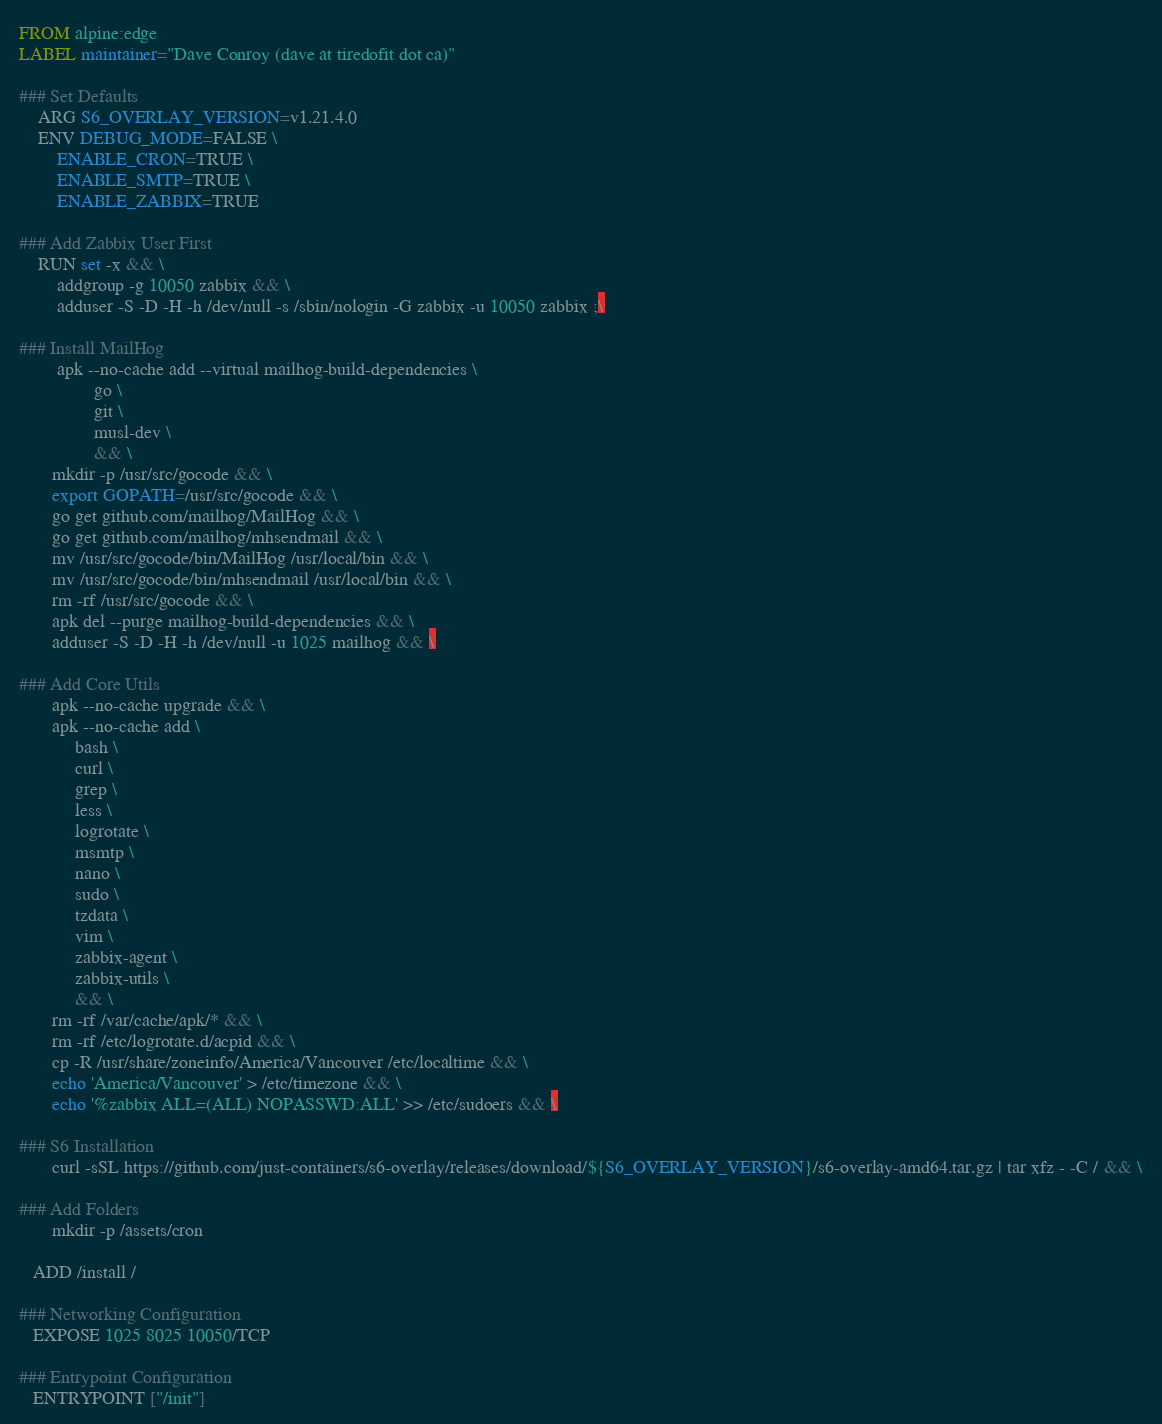<code> <loc_0><loc_0><loc_500><loc_500><_Dockerfile_>FROM alpine:edge
LABEL maintainer="Dave Conroy (dave at tiredofit dot ca)"

### Set Defaults
    ARG S6_OVERLAY_VERSION=v1.21.4.0 
    ENV DEBUG_MODE=FALSE \
        ENABLE_CRON=TRUE \
        ENABLE_SMTP=TRUE \
        ENABLE_ZABBIX=TRUE

### Add Zabbix User First
    RUN set -x && \
        addgroup -g 10050 zabbix && \
        adduser -S -D -H -h /dev/null -s /sbin/nologin -G zabbix -u 10050 zabbix ;\

### Install MailHog
        apk --no-cache add --virtual mailhog-build-dependencies \
                go \
                git \
                musl-dev \
                && \
       mkdir -p /usr/src/gocode && \
       export GOPATH=/usr/src/gocode && \
       go get github.com/mailhog/MailHog && \
       go get github.com/mailhog/mhsendmail && \
       mv /usr/src/gocode/bin/MailHog /usr/local/bin && \
       mv /usr/src/gocode/bin/mhsendmail /usr/local/bin && \
       rm -rf /usr/src/gocode && \
       apk del --purge mailhog-build-dependencies && \
       adduser -S -D -H -h /dev/null -u 1025 mailhog && \

### Add Core Utils
       apk --no-cache upgrade && \
       apk --no-cache add \
            bash \
            curl \
            grep \
            less \
            logrotate \
            msmtp \
            nano \
            sudo \
            tzdata \
            vim \
            zabbix-agent \
            zabbix-utils \
            && \
       rm -rf /var/cache/apk/* && \
       rm -rf /etc/logrotate.d/acpid && \
       cp -R /usr/share/zoneinfo/America/Vancouver /etc/localtime && \
       echo 'America/Vancouver' > /etc/timezone && \
       echo '%zabbix ALL=(ALL) NOPASSWD:ALL' >> /etc/sudoers && \

### S6 Installation
       curl -sSL https://github.com/just-containers/s6-overlay/releases/download/${S6_OVERLAY_VERSION}/s6-overlay-amd64.tar.gz | tar xfz - -C / && \
   
### Add Folders
       mkdir -p /assets/cron

   ADD /install /

### Networking Configuration
   EXPOSE 1025 8025 10050/TCP 

### Entrypoint Configuration
   ENTRYPOINT ["/init"]
</code> 